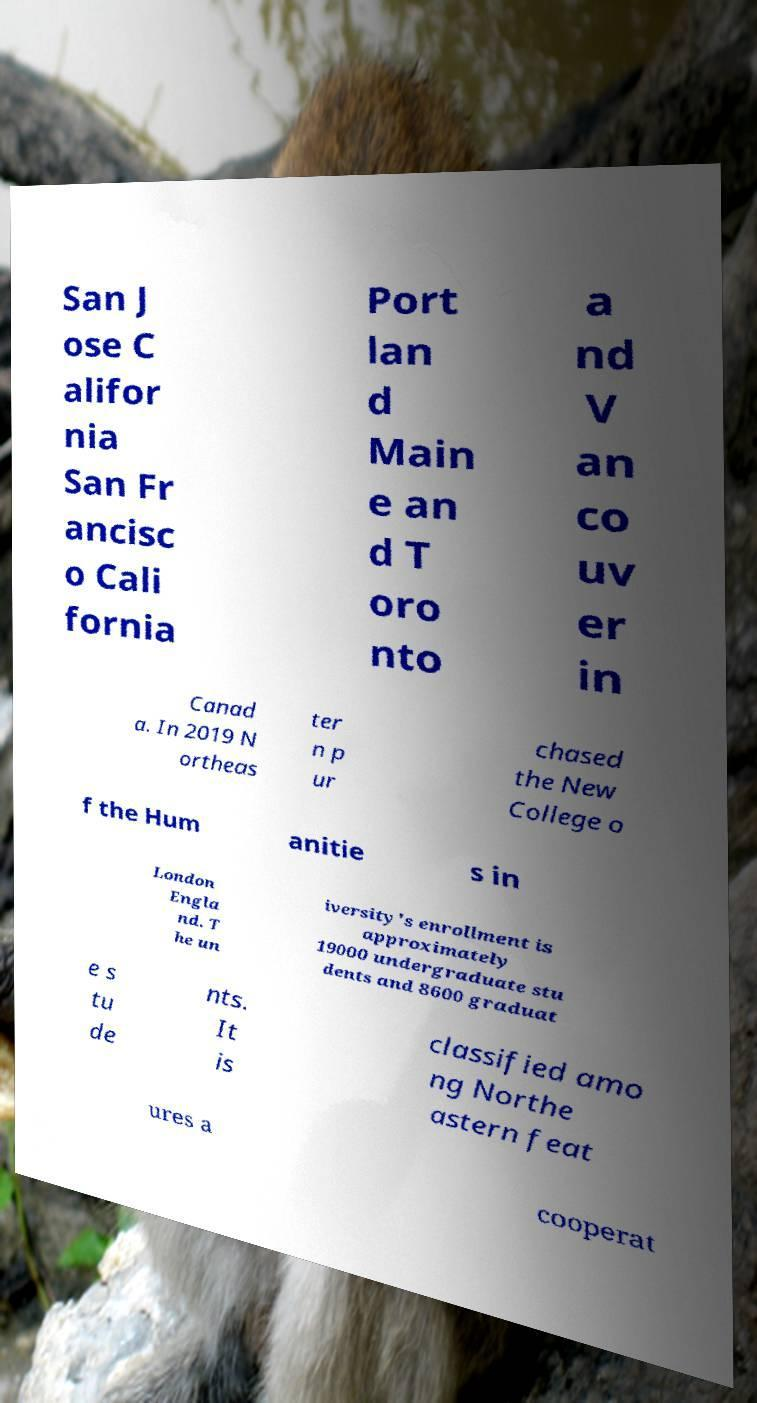Could you extract and type out the text from this image? San J ose C alifor nia San Fr ancisc o Cali fornia Port lan d Main e an d T oro nto a nd V an co uv er in Canad a. In 2019 N ortheas ter n p ur chased the New College o f the Hum anitie s in London Engla nd. T he un iversity's enrollment is approximately 19000 undergraduate stu dents and 8600 graduat e s tu de nts. It is classified amo ng Northe astern feat ures a cooperat 